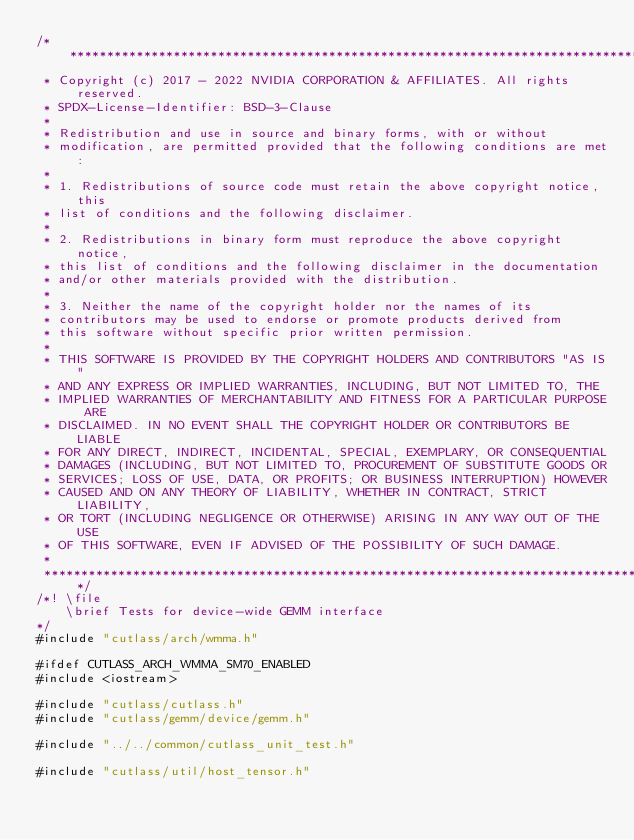Convert code to text. <code><loc_0><loc_0><loc_500><loc_500><_Cuda_>/***************************************************************************************************
 * Copyright (c) 2017 - 2022 NVIDIA CORPORATION & AFFILIATES. All rights reserved.
 * SPDX-License-Identifier: BSD-3-Clause
 *
 * Redistribution and use in source and binary forms, with or without
 * modification, are permitted provided that the following conditions are met:
 *
 * 1. Redistributions of source code must retain the above copyright notice, this
 * list of conditions and the following disclaimer.
 *
 * 2. Redistributions in binary form must reproduce the above copyright notice,
 * this list of conditions and the following disclaimer in the documentation
 * and/or other materials provided with the distribution.
 *
 * 3. Neither the name of the copyright holder nor the names of its
 * contributors may be used to endorse or promote products derived from
 * this software without specific prior written permission.
 *
 * THIS SOFTWARE IS PROVIDED BY THE COPYRIGHT HOLDERS AND CONTRIBUTORS "AS IS"
 * AND ANY EXPRESS OR IMPLIED WARRANTIES, INCLUDING, BUT NOT LIMITED TO, THE
 * IMPLIED WARRANTIES OF MERCHANTABILITY AND FITNESS FOR A PARTICULAR PURPOSE ARE
 * DISCLAIMED. IN NO EVENT SHALL THE COPYRIGHT HOLDER OR CONTRIBUTORS BE LIABLE
 * FOR ANY DIRECT, INDIRECT, INCIDENTAL, SPECIAL, EXEMPLARY, OR CONSEQUENTIAL
 * DAMAGES (INCLUDING, BUT NOT LIMITED TO, PROCUREMENT OF SUBSTITUTE GOODS OR
 * SERVICES; LOSS OF USE, DATA, OR PROFITS; OR BUSINESS INTERRUPTION) HOWEVER
 * CAUSED AND ON ANY THEORY OF LIABILITY, WHETHER IN CONTRACT, STRICT LIABILITY,
 * OR TORT (INCLUDING NEGLIGENCE OR OTHERWISE) ARISING IN ANY WAY OUT OF THE USE
 * OF THIS SOFTWARE, EVEN IF ADVISED OF THE POSSIBILITY OF SUCH DAMAGE.
 *
 **************************************************************************************************/
/*! \file
    \brief Tests for device-wide GEMM interface
*/
#include "cutlass/arch/wmma.h"

#ifdef CUTLASS_ARCH_WMMA_SM70_ENABLED
#include <iostream>

#include "cutlass/cutlass.h"
#include "cutlass/gemm/device/gemm.h"

#include "../../common/cutlass_unit_test.h"

#include "cutlass/util/host_tensor.h"</code> 